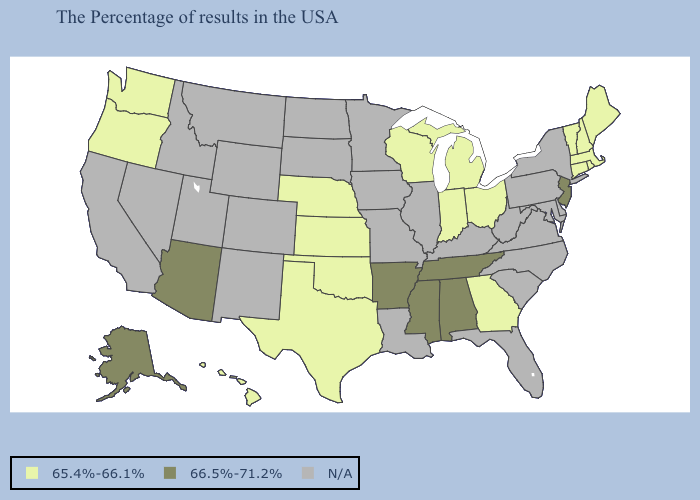Which states have the lowest value in the USA?
Keep it brief. Maine, Massachusetts, Rhode Island, New Hampshire, Vermont, Connecticut, Ohio, Georgia, Michigan, Indiana, Wisconsin, Kansas, Nebraska, Oklahoma, Texas, Washington, Oregon, Hawaii. How many symbols are there in the legend?
Answer briefly. 3. Name the states that have a value in the range N/A?
Keep it brief. New York, Delaware, Maryland, Pennsylvania, Virginia, North Carolina, South Carolina, West Virginia, Florida, Kentucky, Illinois, Louisiana, Missouri, Minnesota, Iowa, South Dakota, North Dakota, Wyoming, Colorado, New Mexico, Utah, Montana, Idaho, Nevada, California. Which states have the lowest value in the USA?
Short answer required. Maine, Massachusetts, Rhode Island, New Hampshire, Vermont, Connecticut, Ohio, Georgia, Michigan, Indiana, Wisconsin, Kansas, Nebraska, Oklahoma, Texas, Washington, Oregon, Hawaii. What is the highest value in the West ?
Be succinct. 66.5%-71.2%. Name the states that have a value in the range 65.4%-66.1%?
Be succinct. Maine, Massachusetts, Rhode Island, New Hampshire, Vermont, Connecticut, Ohio, Georgia, Michigan, Indiana, Wisconsin, Kansas, Nebraska, Oklahoma, Texas, Washington, Oregon, Hawaii. Does Washington have the highest value in the USA?
Answer briefly. No. Name the states that have a value in the range 65.4%-66.1%?
Keep it brief. Maine, Massachusetts, Rhode Island, New Hampshire, Vermont, Connecticut, Ohio, Georgia, Michigan, Indiana, Wisconsin, Kansas, Nebraska, Oklahoma, Texas, Washington, Oregon, Hawaii. Which states have the lowest value in the USA?
Write a very short answer. Maine, Massachusetts, Rhode Island, New Hampshire, Vermont, Connecticut, Ohio, Georgia, Michigan, Indiana, Wisconsin, Kansas, Nebraska, Oklahoma, Texas, Washington, Oregon, Hawaii. Which states have the highest value in the USA?
Keep it brief. New Jersey, Alabama, Tennessee, Mississippi, Arkansas, Arizona, Alaska. What is the value of Alabama?
Write a very short answer. 66.5%-71.2%. 